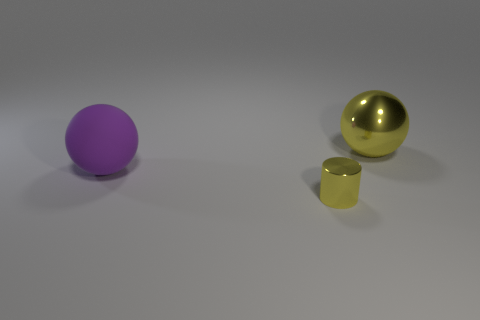Are there any other things that have the same size as the cylinder?
Offer a very short reply. No. How many metallic objects are cylinders or big purple objects?
Provide a short and direct response. 1. There is another big thing that is the same shape as the purple rubber thing; what color is it?
Your response must be concise. Yellow. What number of balls have the same color as the small object?
Provide a short and direct response. 1. There is a shiny thing that is behind the large purple matte ball; is there a tiny shiny thing that is behind it?
Ensure brevity in your answer.  No. How many things are both in front of the big purple object and behind the small shiny object?
Ensure brevity in your answer.  0. How many yellow cylinders have the same material as the large yellow ball?
Your response must be concise. 1. There is a yellow object that is in front of the metal object on the right side of the yellow cylinder; what size is it?
Give a very brief answer. Small. Are there any small yellow metallic objects that have the same shape as the purple thing?
Offer a very short reply. No. There is a yellow shiny thing that is in front of the purple thing; is its size the same as the object that is behind the purple object?
Your answer should be very brief. No. 